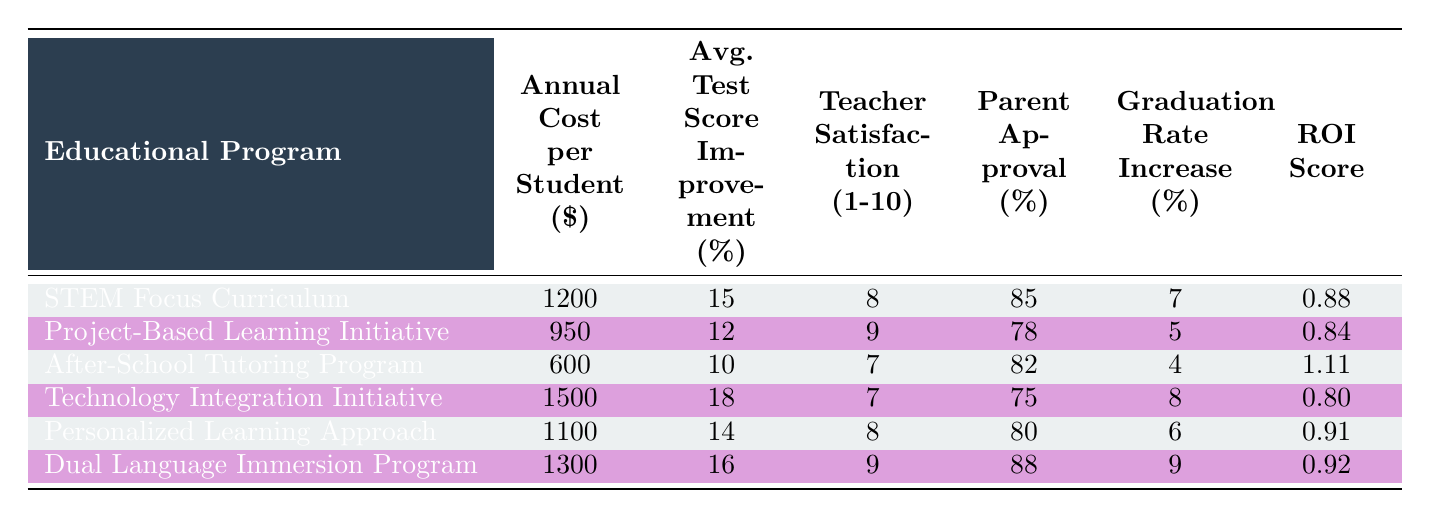What is the annual cost per student for the After-School Tutoring Program? The annual cost per student for the After-School Tutoring Program is listed directly in the table under the "Annual Cost per Student ($)" column, which shows $600.
Answer: 600 Which educational program has the highest average improvement in test scores? The highest average improvement in test scores can be found by comparing the values in the "Average Improvement in Test Scores (%)" column. The Technology Integration Initiative has the highest value of 18%.
Answer: Technology Integration Initiative Is the Parent Approval Rating for the Dual Language Immersion Program above 85%? Looking at the "Parent Approval Rating (%)" for the Dual Language Immersion Program, it shows 88%, which is indeed above 85%. Therefore, the statement is true.
Answer: Yes What is the difference in the annual cost per student between the STEM Focus Curriculum and the Project-Based Learning Initiative? The annual cost for the STEM Focus Curriculum is $1200, and for the Project-Based Learning Initiative, it is $950. The difference is calculated as 1200 - 950 = 250.
Answer: 250 Which program offers the highest Return on Investment (ROI) score? To find the highest ROI score, we check the values in the "ROI Score" column. The After-School Tutoring Program shows the highest ROI score of 1.11.
Answer: After-School Tutoring Program What is the average Teacher Satisfaction Rating for all programs listed? The Teacher Satisfaction Ratings are 8, 9, 7, 7, 8, and 9. Adding them gives us 8 + 9 + 7 + 7 + 8 + 9 = 58. There are 6 programs, so the average is 58 / 6 = 9.67.
Answer: 9.67 Is the Long-term Graduation Rate Increase from the Technology Integration Initiative higher than that of the Personalized Learning Approach? The Long-term Graduation Rate Increase for Technology Integration Initiative is 8% and for the Personalized Learning Approach is 6%. Since 8% is greater than 6%, the statement is true.
Answer: Yes Which educational program has the lowest Teacher Satisfaction Rating? We look at the "Teacher Satisfaction Rating (1-10)" column and find that the After-School Tutoring Program has the lowest rating of 7.
Answer: After-School Tutoring Program What is the median Annual Cost per Student for the programs listed? The costs per student are 600, 950, 1100, 1200, 1300, and 1500. Arranging them in order gives us 600, 950, 1100, 1200, 1300, 1500. The median is the average of the two middle values (1100 and 1200), so (1100 + 1200) / 2 = 1150.
Answer: 1150 